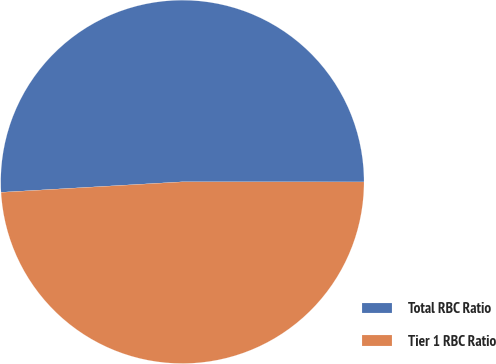Convert chart. <chart><loc_0><loc_0><loc_500><loc_500><pie_chart><fcel>Total RBC Ratio<fcel>Tier 1 RBC Ratio<nl><fcel>50.93%<fcel>49.07%<nl></chart> 